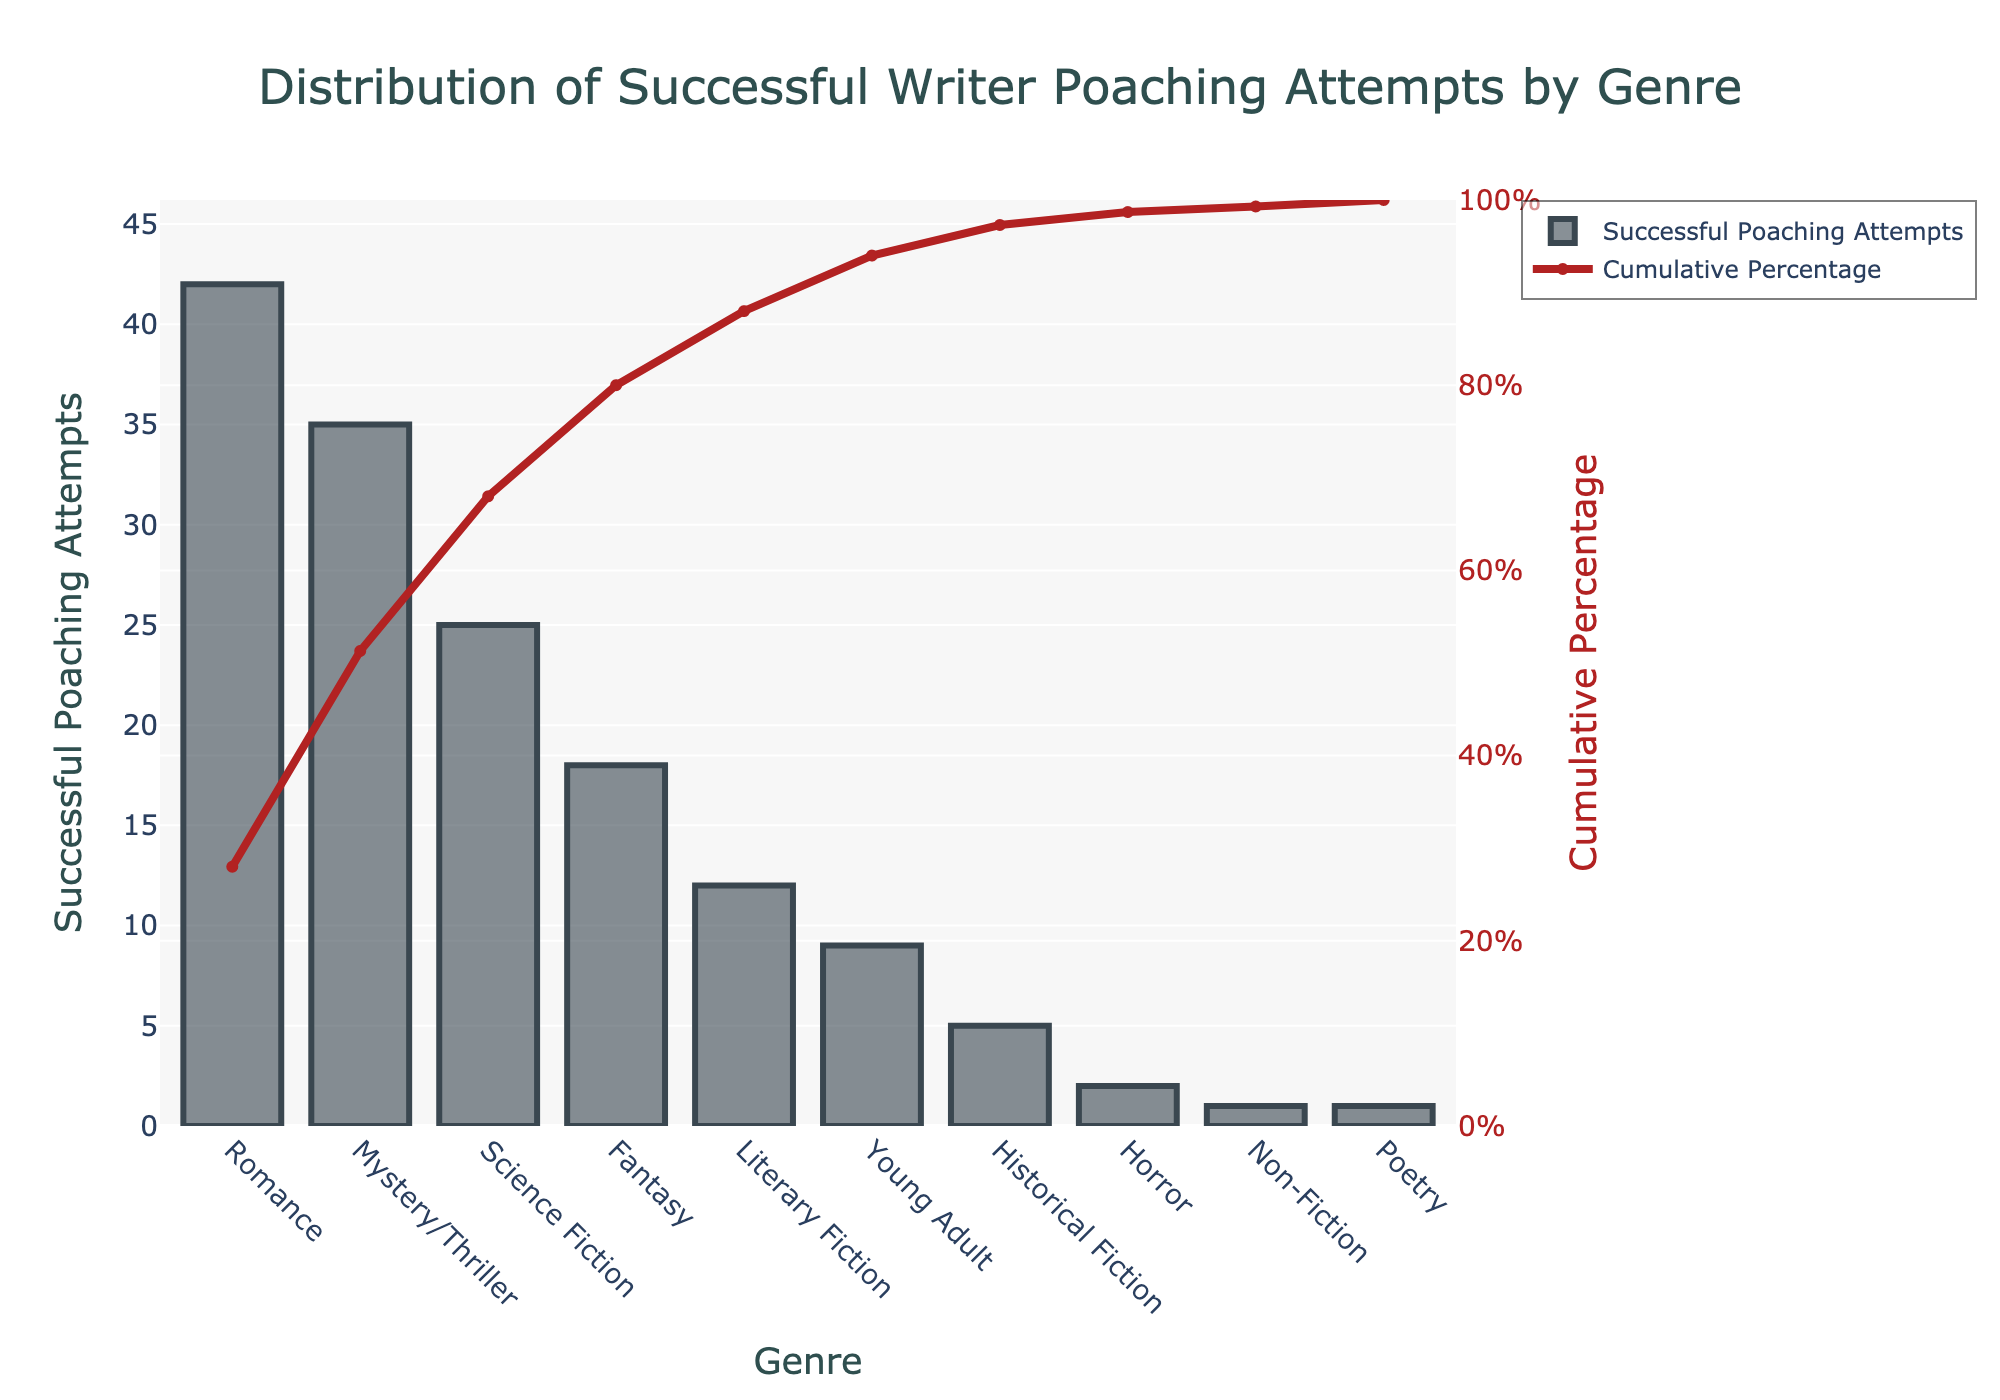What genre has the highest number of successful poaching attempts? The bar chart shows the height of bars representing the number of successful poaching attempts for each genre. The Romance genre has the tallest bar, indicating it has the highest number of successful poaching attempts.
Answer: Romance What is the cumulative percentage after Romance and Mystery/Thriller genres combined? The cumulative percentage shown as a line graph reaches 51.3% after including both Romance and Mystery/Thriller genres.
Answer: 51.3% How many successful poaching attempts were made for the Poetry genre? The bar representing the Poetry genre is very short, and the table indicates there was only one successful poaching attempt for this genre.
Answer: 1 Which genre has the lowest number of successful poaching attempts? The bar chart shows line segments of varying heights for each genre, and the genres with the shortest bars, indicating the lowest successful poaching attempts, are Horror and Non-Fiction with 1 attempt each.
Answer: Poetry How do the successful poaching attempts in Science Fiction compare to those in Fantasy? By comparing the heights of the bars, Science Fiction has a taller bar indicating 25 successful poaching attempts, while Fantasy has a shorter bar with 18 attempts.
Answer: Science Fiction has more than Fantasy What is the cumulative percentage after Literary Fiction? The line graph shows the cumulative percentage reaching 88.0% after including Literary Fiction.
Answer: 88.0% What are the total successful poaching attempts for genres with individual attempts less than or equal to 5? The genres Historical Fiction (5), Horror (2), Non-Fiction (1), and Poetry (1) all have individual attempts less than or equal to 5. Summing these gives 5 + 2 + 1 + 1 = 9.
Answer: 9 What is the range of successful poaching attempts for the displayed genres? The range is calculated as the difference between the maximum and minimum values in the bar chart. The maximum value is 42 (Romance) and the minimum value is 1 (Poetry, Non-Fiction). Thus, 42 - 1 = 41.
Answer: 41 Which two genres together make up approximately 80% of the cumulative percentage? Referring to the cumulative percentage line, Science Fiction plus another genre would slightly exceed 68%, and adding Fantasy brings it to exactly 80%. So, Romance, Mystery/Thriller, and Science Fiction alone.
Answer: Romance, Mystery/Thriller, and Science Fiction together What is the difference in successful poaching attempts between the top two genres? The top two genres by successful poaching attempts are Romance (42) and Mystery/Thriller (35). The difference is 42 - 35 = 7.
Answer: 7 